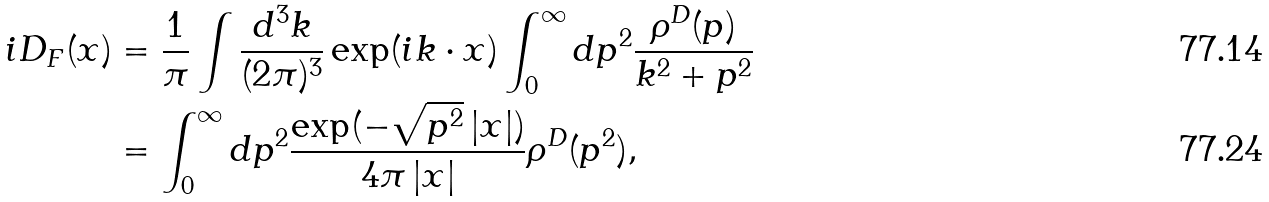Convert formula to latex. <formula><loc_0><loc_0><loc_500><loc_500>i D _ { F } ( x ) & = \frac { 1 } { \pi } \int \frac { d ^ { 3 } k } { ( 2 \pi ) ^ { 3 } } \exp ( i k \cdot x ) \int _ { 0 } ^ { \infty } d p ^ { 2 } \frac { \rho ^ { D } ( p ) } { k ^ { 2 } + p ^ { 2 } } \\ & = \int _ { 0 } ^ { \infty } d p ^ { 2 } \frac { \exp ( - \sqrt { p ^ { 2 } } \left | x \right | ) } { 4 \pi \left | x \right | } \rho ^ { D } ( p ^ { 2 } ) ,</formula> 